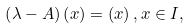Convert formula to latex. <formula><loc_0><loc_0><loc_500><loc_500>\left ( \lambda - A \right ) \left ( x \right ) = \left ( x \right ) , x \in I ,</formula> 